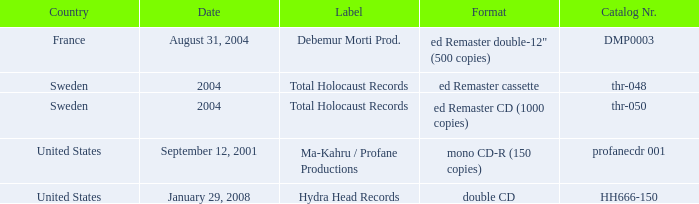What country is the Debemur Morti prod. label from? France. Parse the full table. {'header': ['Country', 'Date', 'Label', 'Format', 'Catalog Nr.'], 'rows': [['France', 'August 31, 2004', 'Debemur Morti Prod.', 'ed Remaster double-12" (500 copies)', 'DMP0003'], ['Sweden', '2004', 'Total Holocaust Records', 'ed Remaster cassette', 'thr-048'], ['Sweden', '2004', 'Total Holocaust Records', 'ed Remaster CD (1000 copies)', 'thr-050'], ['United States', 'September 12, 2001', 'Ma-Kahru / Profane Productions', 'mono CD-R (150 copies)', 'profanecdr 001'], ['United States', 'January 29, 2008', 'Hydra Head Records', 'double CD', 'HH666-150']]} 